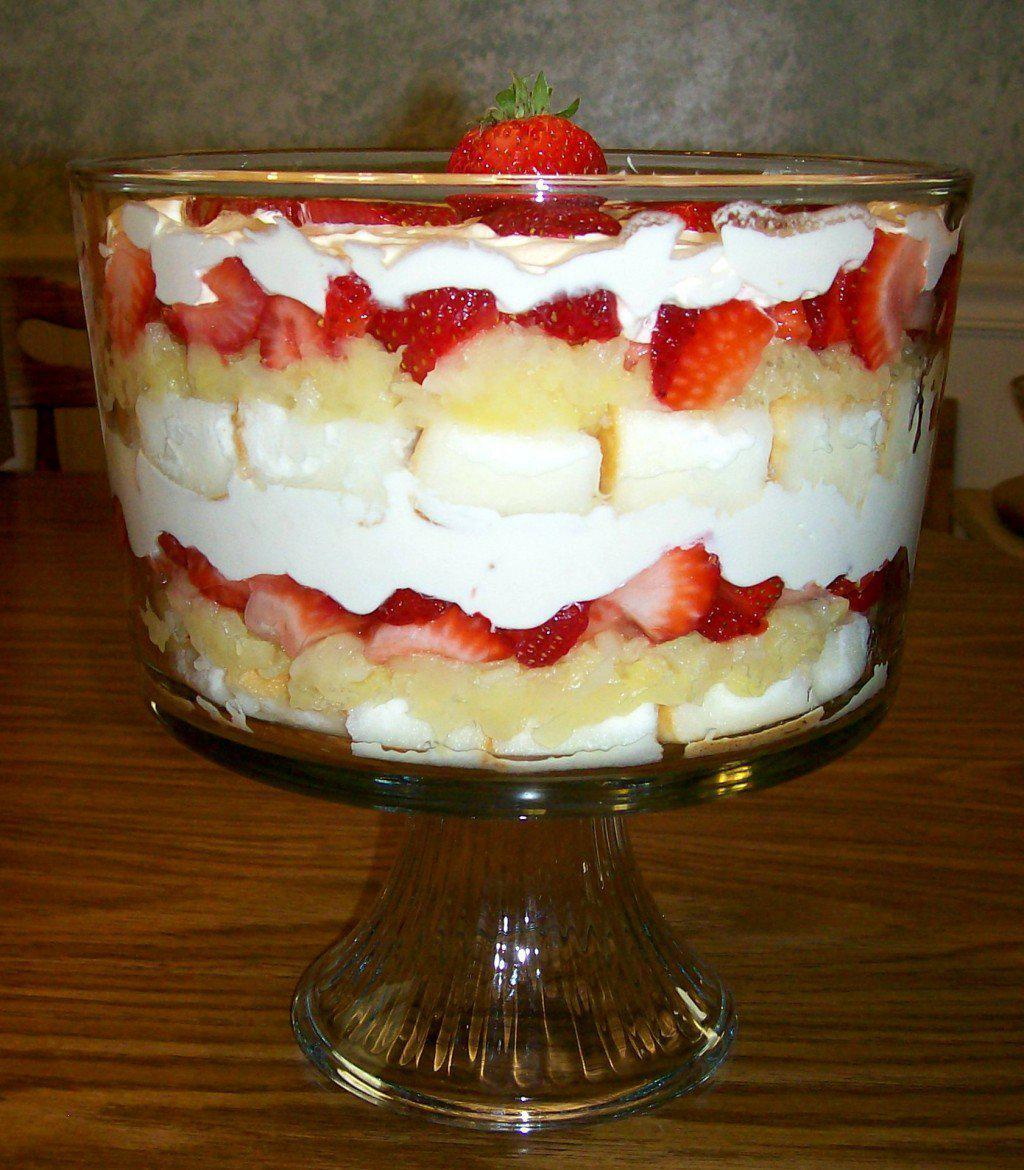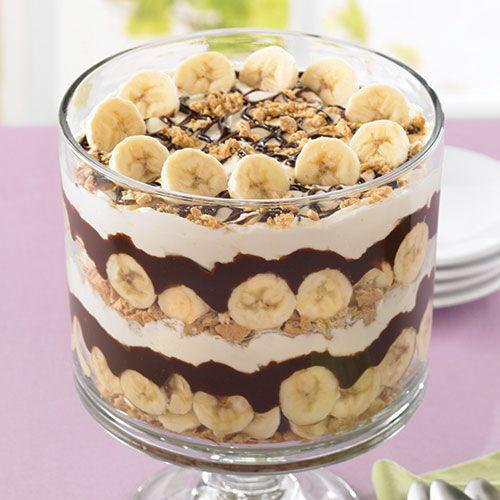The first image is the image on the left, the second image is the image on the right. For the images shown, is this caption "Berries top a trifle in one image." true? Answer yes or no. Yes. The first image is the image on the left, the second image is the image on the right. Considering the images on both sides, is "Part of some utensils are visible." valid? Answer yes or no. No. 